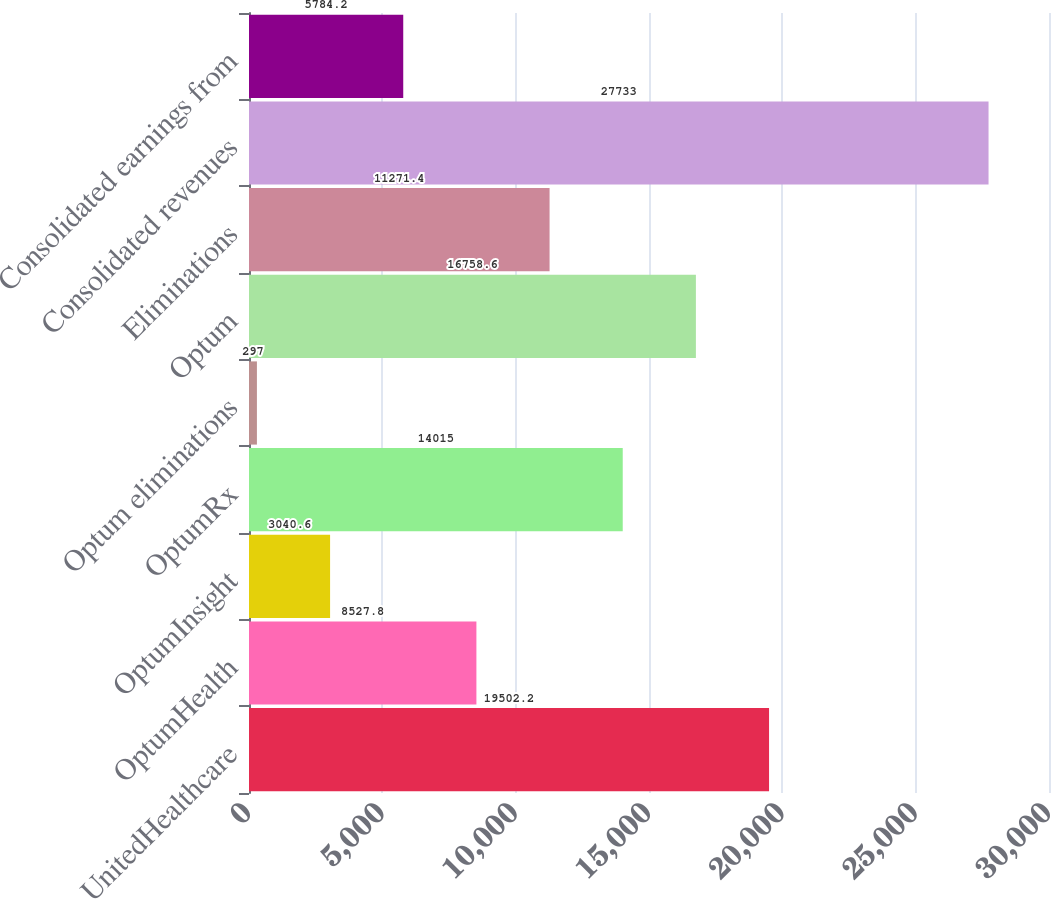Convert chart to OTSL. <chart><loc_0><loc_0><loc_500><loc_500><bar_chart><fcel>UnitedHealthcare<fcel>OptumHealth<fcel>OptumInsight<fcel>OptumRx<fcel>Optum eliminations<fcel>Optum<fcel>Eliminations<fcel>Consolidated revenues<fcel>Consolidated earnings from<nl><fcel>19502.2<fcel>8527.8<fcel>3040.6<fcel>14015<fcel>297<fcel>16758.6<fcel>11271.4<fcel>27733<fcel>5784.2<nl></chart> 